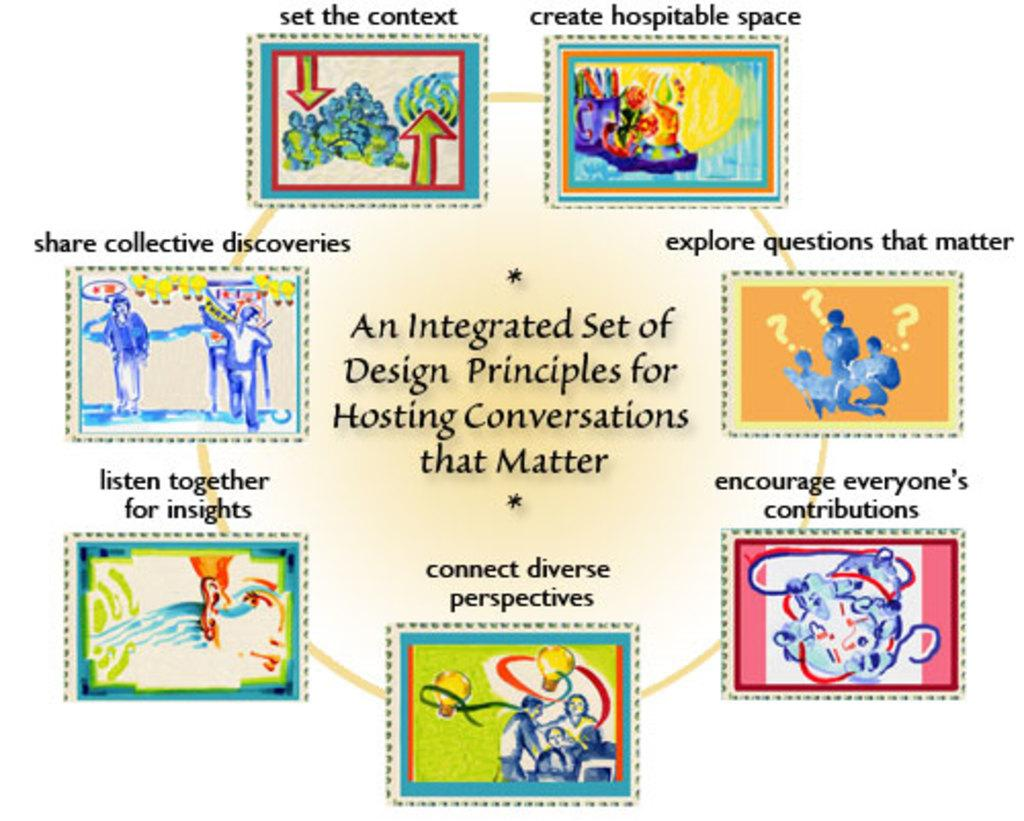<image>
Offer a succinct explanation of the picture presented. Design art that has an Integrated Set of Design Principles for Hosting Conversations that Matter. 